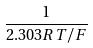Convert formula to latex. <formula><loc_0><loc_0><loc_500><loc_500>\frac { 1 } { 2 . 3 0 3 R T / F }</formula> 